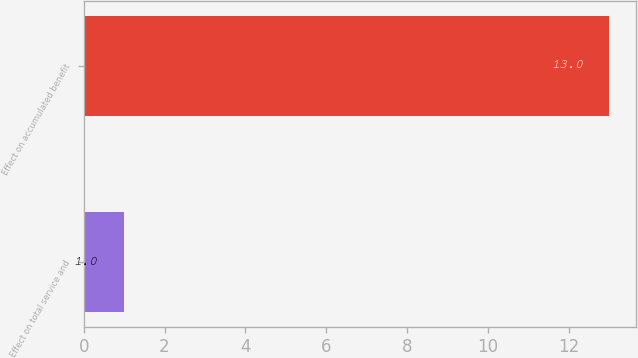<chart> <loc_0><loc_0><loc_500><loc_500><bar_chart><fcel>Effect on total service and<fcel>Effect on accumulated benefit<nl><fcel>1<fcel>13<nl></chart> 